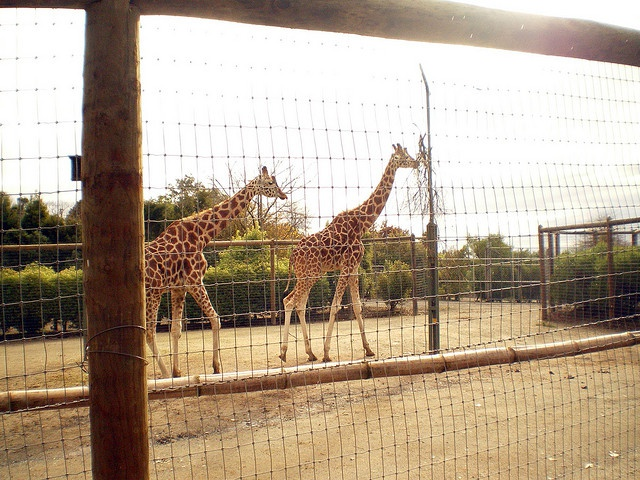Describe the objects in this image and their specific colors. I can see giraffe in black, maroon, gray, tan, and brown tones and giraffe in black, gray, maroon, and tan tones in this image. 